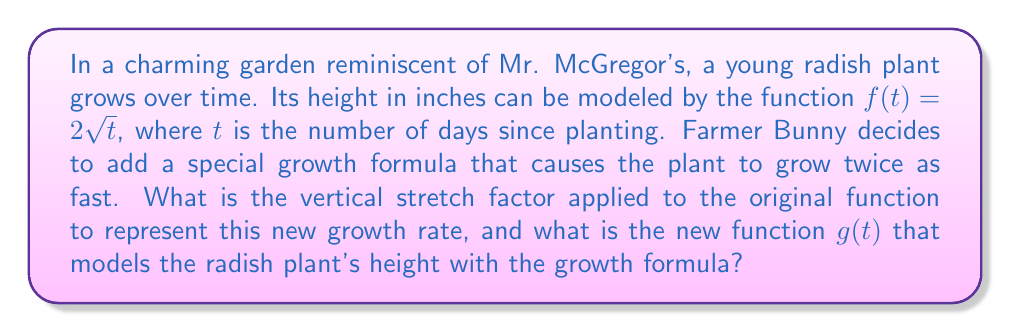Help me with this question. To solve this problem, we need to understand vertical stretches of functions:

1) A vertical stretch of a function $f(x)$ by a factor of $a$ is represented as $g(x) = af(x)$, where $a > 1$.

2) In this case, the plant is growing twice as fast, so the stretch factor $a = 2$.

3) The original function is $f(t) = 2\sqrt{t}$.

4) To apply the vertical stretch, we multiply the entire function by 2:

   $g(t) = 2f(t) = 2(2\sqrt{t}) = 4\sqrt{t}$

5) Therefore, the new function that models the radish plant's height with the growth formula is $g(t) = 4\sqrt{t}$.

The vertical stretch factor is 2, which means the plant's height at any given time will be twice what it was under the original growth model.
Answer: The vertical stretch factor is 2, and the new function is $g(t) = 4\sqrt{t}$. 